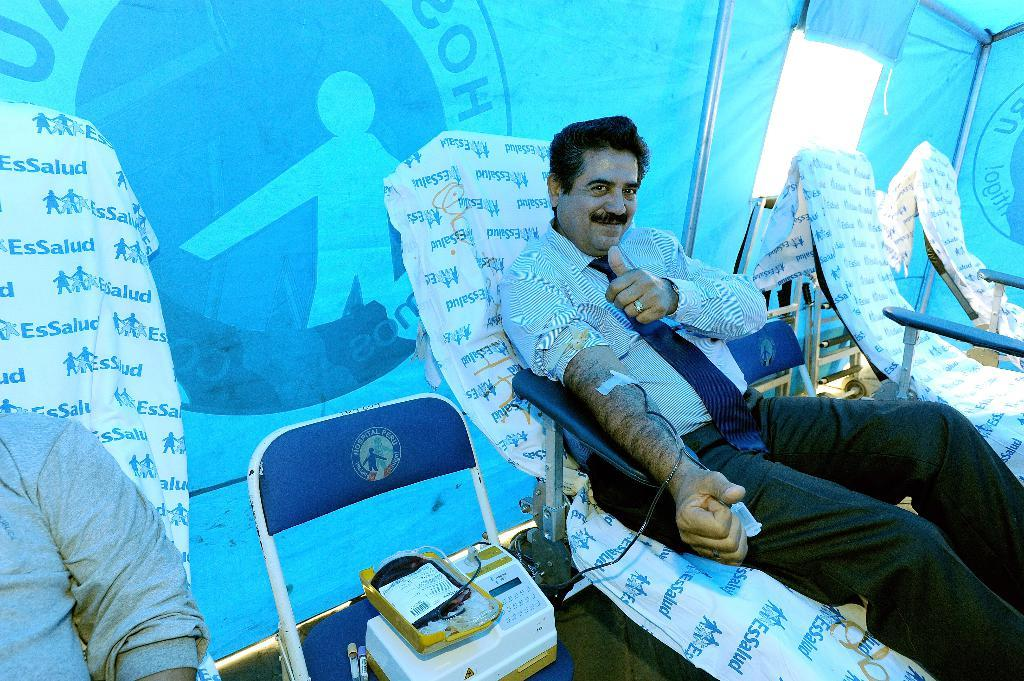How many people are in the image? There are two people in the image. What are the two people doing in the image? The two people are leaning on a bed, and one person is donating blood. How does the person donating blood feel about the process? The person donating blood is showing a thumb up, which suggests they are positive or satisfied with the process. What type of wing can be seen on the children in the image? There are no children or wings present in the image. What is the texture of the bed in the image? The texture of the bed cannot be determined from the image, as it only provides visual information about the people and their actions. 